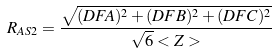Convert formula to latex. <formula><loc_0><loc_0><loc_500><loc_500>R _ { A S 2 } = \frac { \sqrt { ( D F A ) ^ { 2 } + ( D F B ) ^ { 2 } + ( D F C ) ^ { 2 } } } { \sqrt { 6 } < Z > }</formula> 